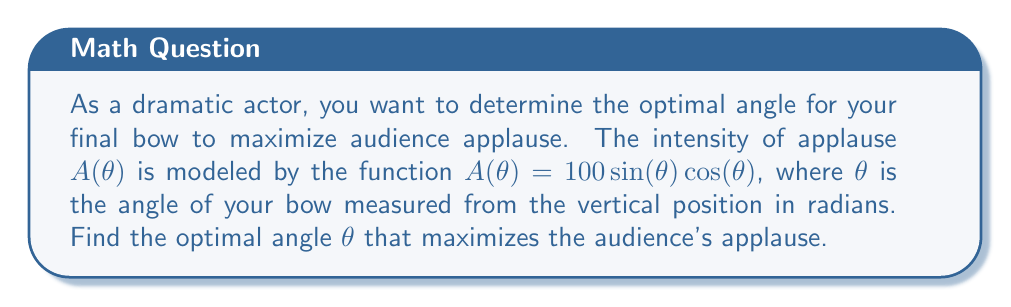Can you answer this question? To find the optimal angle that maximizes the audience's applause, we need to find the maximum of the function $A(\theta) = 100\sin(\theta)\cos(\theta)$. We can do this by following these steps:

1) First, let's simplify the function using the trigonometric identity $\sin(2\theta) = 2\sin(\theta)\cos(\theta)$:

   $A(\theta) = 100\sin(\theta)\cos(\theta) = 50\sin(2\theta)$

2) To find the maximum, we need to find where the derivative of $A(\theta)$ equals zero:

   $\frac{dA}{d\theta} = 50 \cdot 2\cos(2\theta) = 100\cos(2\theta)$

3) Set the derivative equal to zero and solve:

   $100\cos(2\theta) = 0$
   $\cos(2\theta) = 0$

4) The cosine function equals zero when its argument is $\frac{\pi}{2}$ or $\frac{3\pi}{2}$ radians. So:

   $2\theta = \frac{\pi}{2}$ or $2\theta = \frac{3\pi}{2}$
   $\theta = \frac{\pi}{4}$ or $\theta = \frac{3\pi}{4}$

5) To determine which of these is the maximum (rather than the minimum), we can check the second derivative:

   $\frac{d^2A}{d\theta^2} = -200\sin(2\theta)$

   At $\theta = \frac{\pi}{4}$, $\frac{d^2A}{d\theta^2} = -200\sin(\frac{\pi}{2}) = -200 < 0$, indicating a maximum.
   At $\theta = \frac{3\pi}{4}$, $\frac{d^2A}{d\theta^2} = -200\sin(\frac{3\pi}{2}) = 200 > 0$, indicating a minimum.

Therefore, the optimal angle for maximizing applause is $\frac{\pi}{4}$ radians or 45 degrees from the vertical.
Answer: $\frac{\pi}{4}$ radians or 45° 